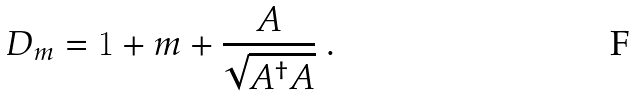Convert formula to latex. <formula><loc_0><loc_0><loc_500><loc_500>D _ { m } = 1 + m + \frac { A } { \sqrt { A ^ { \dagger } A } } \ .</formula> 